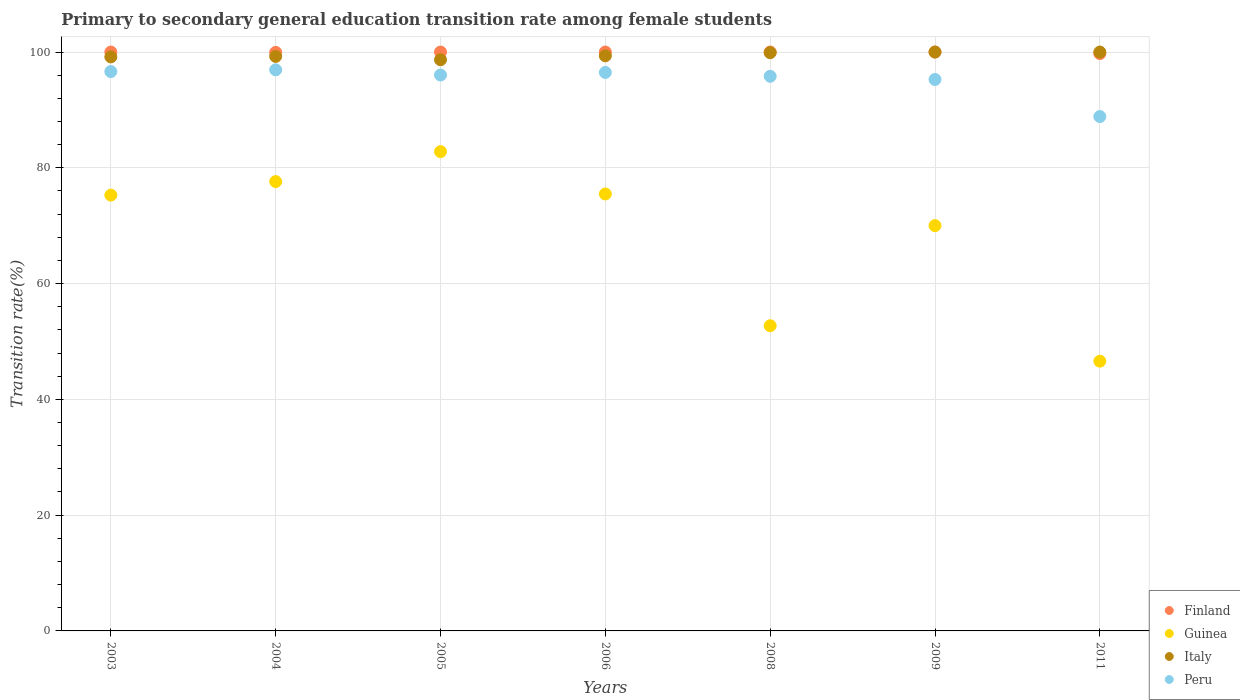How many different coloured dotlines are there?
Your answer should be very brief. 4. Is the number of dotlines equal to the number of legend labels?
Your answer should be compact. Yes. What is the transition rate in Guinea in 2003?
Keep it short and to the point. 75.28. Across all years, what is the maximum transition rate in Italy?
Your response must be concise. 100. Across all years, what is the minimum transition rate in Guinea?
Your answer should be very brief. 46.59. In which year was the transition rate in Peru maximum?
Offer a terse response. 2004. What is the total transition rate in Guinea in the graph?
Your answer should be compact. 480.51. What is the difference between the transition rate in Italy in 2003 and that in 2004?
Provide a short and direct response. -0.09. What is the difference between the transition rate in Italy in 2003 and the transition rate in Peru in 2008?
Ensure brevity in your answer.  3.35. What is the average transition rate in Guinea per year?
Your answer should be compact. 68.64. In the year 2008, what is the difference between the transition rate in Guinea and transition rate in Italy?
Your answer should be compact. -47.17. In how many years, is the transition rate in Finland greater than 68 %?
Make the answer very short. 7. What is the ratio of the transition rate in Finland in 2004 to that in 2005?
Offer a very short reply. 1. Is the difference between the transition rate in Guinea in 2004 and 2009 greater than the difference between the transition rate in Italy in 2004 and 2009?
Offer a terse response. Yes. What is the difference between the highest and the second highest transition rate in Guinea?
Offer a very short reply. 5.18. What is the difference between the highest and the lowest transition rate in Guinea?
Your answer should be compact. 36.2. In how many years, is the transition rate in Peru greater than the average transition rate in Peru taken over all years?
Your answer should be compact. 6. Is it the case that in every year, the sum of the transition rate in Guinea and transition rate in Peru  is greater than the sum of transition rate in Finland and transition rate in Italy?
Offer a terse response. No. Is it the case that in every year, the sum of the transition rate in Peru and transition rate in Guinea  is greater than the transition rate in Italy?
Offer a very short reply. Yes. Is the transition rate in Italy strictly less than the transition rate in Peru over the years?
Your response must be concise. No. How many dotlines are there?
Your answer should be very brief. 4. How many years are there in the graph?
Provide a short and direct response. 7. Are the values on the major ticks of Y-axis written in scientific E-notation?
Give a very brief answer. No. How are the legend labels stacked?
Offer a terse response. Vertical. What is the title of the graph?
Offer a terse response. Primary to secondary general education transition rate among female students. Does "Trinidad and Tobago" appear as one of the legend labels in the graph?
Your answer should be compact. No. What is the label or title of the X-axis?
Make the answer very short. Years. What is the label or title of the Y-axis?
Offer a terse response. Transition rate(%). What is the Transition rate(%) of Finland in 2003?
Your answer should be compact. 100. What is the Transition rate(%) of Guinea in 2003?
Your response must be concise. 75.28. What is the Transition rate(%) of Italy in 2003?
Provide a succinct answer. 99.16. What is the Transition rate(%) of Peru in 2003?
Provide a short and direct response. 96.63. What is the Transition rate(%) in Finland in 2004?
Make the answer very short. 99.95. What is the Transition rate(%) in Guinea in 2004?
Give a very brief answer. 77.62. What is the Transition rate(%) in Italy in 2004?
Provide a succinct answer. 99.24. What is the Transition rate(%) of Peru in 2004?
Provide a succinct answer. 96.92. What is the Transition rate(%) in Finland in 2005?
Your response must be concise. 100. What is the Transition rate(%) of Guinea in 2005?
Provide a short and direct response. 82.8. What is the Transition rate(%) of Italy in 2005?
Provide a short and direct response. 98.67. What is the Transition rate(%) of Peru in 2005?
Your answer should be very brief. 96.03. What is the Transition rate(%) in Guinea in 2006?
Offer a very short reply. 75.48. What is the Transition rate(%) of Italy in 2006?
Provide a short and direct response. 99.35. What is the Transition rate(%) of Peru in 2006?
Provide a succinct answer. 96.47. What is the Transition rate(%) of Finland in 2008?
Keep it short and to the point. 100. What is the Transition rate(%) in Guinea in 2008?
Keep it short and to the point. 52.72. What is the Transition rate(%) of Italy in 2008?
Offer a very short reply. 99.89. What is the Transition rate(%) in Peru in 2008?
Offer a very short reply. 95.81. What is the Transition rate(%) of Finland in 2009?
Ensure brevity in your answer.  100. What is the Transition rate(%) of Guinea in 2009?
Your answer should be very brief. 70.02. What is the Transition rate(%) in Italy in 2009?
Provide a succinct answer. 100. What is the Transition rate(%) of Peru in 2009?
Ensure brevity in your answer.  95.26. What is the Transition rate(%) of Finland in 2011?
Your response must be concise. 99.73. What is the Transition rate(%) of Guinea in 2011?
Your answer should be very brief. 46.59. What is the Transition rate(%) in Italy in 2011?
Offer a very short reply. 100. What is the Transition rate(%) of Peru in 2011?
Provide a short and direct response. 88.85. Across all years, what is the maximum Transition rate(%) of Finland?
Ensure brevity in your answer.  100. Across all years, what is the maximum Transition rate(%) in Guinea?
Offer a terse response. 82.8. Across all years, what is the maximum Transition rate(%) of Italy?
Ensure brevity in your answer.  100. Across all years, what is the maximum Transition rate(%) in Peru?
Make the answer very short. 96.92. Across all years, what is the minimum Transition rate(%) in Finland?
Make the answer very short. 99.73. Across all years, what is the minimum Transition rate(%) in Guinea?
Offer a terse response. 46.59. Across all years, what is the minimum Transition rate(%) in Italy?
Keep it short and to the point. 98.67. Across all years, what is the minimum Transition rate(%) of Peru?
Make the answer very short. 88.85. What is the total Transition rate(%) of Finland in the graph?
Provide a short and direct response. 699.68. What is the total Transition rate(%) in Guinea in the graph?
Keep it short and to the point. 480.51. What is the total Transition rate(%) in Italy in the graph?
Give a very brief answer. 696.3. What is the total Transition rate(%) of Peru in the graph?
Make the answer very short. 665.97. What is the difference between the Transition rate(%) in Finland in 2003 and that in 2004?
Your answer should be compact. 0.05. What is the difference between the Transition rate(%) of Guinea in 2003 and that in 2004?
Keep it short and to the point. -2.34. What is the difference between the Transition rate(%) of Italy in 2003 and that in 2004?
Your answer should be very brief. -0.09. What is the difference between the Transition rate(%) in Peru in 2003 and that in 2004?
Keep it short and to the point. -0.29. What is the difference between the Transition rate(%) in Guinea in 2003 and that in 2005?
Make the answer very short. -7.52. What is the difference between the Transition rate(%) of Italy in 2003 and that in 2005?
Keep it short and to the point. 0.49. What is the difference between the Transition rate(%) of Peru in 2003 and that in 2005?
Offer a very short reply. 0.6. What is the difference between the Transition rate(%) of Guinea in 2003 and that in 2006?
Ensure brevity in your answer.  -0.2. What is the difference between the Transition rate(%) of Italy in 2003 and that in 2006?
Offer a terse response. -0.19. What is the difference between the Transition rate(%) of Peru in 2003 and that in 2006?
Your response must be concise. 0.16. What is the difference between the Transition rate(%) in Finland in 2003 and that in 2008?
Offer a very short reply. 0. What is the difference between the Transition rate(%) of Guinea in 2003 and that in 2008?
Offer a terse response. 22.56. What is the difference between the Transition rate(%) in Italy in 2003 and that in 2008?
Your answer should be very brief. -0.73. What is the difference between the Transition rate(%) of Peru in 2003 and that in 2008?
Provide a succinct answer. 0.82. What is the difference between the Transition rate(%) of Finland in 2003 and that in 2009?
Provide a succinct answer. 0. What is the difference between the Transition rate(%) of Guinea in 2003 and that in 2009?
Offer a very short reply. 5.26. What is the difference between the Transition rate(%) of Italy in 2003 and that in 2009?
Offer a very short reply. -0.84. What is the difference between the Transition rate(%) in Peru in 2003 and that in 2009?
Provide a succinct answer. 1.37. What is the difference between the Transition rate(%) in Finland in 2003 and that in 2011?
Your answer should be compact. 0.27. What is the difference between the Transition rate(%) of Guinea in 2003 and that in 2011?
Offer a very short reply. 28.68. What is the difference between the Transition rate(%) in Italy in 2003 and that in 2011?
Make the answer very short. -0.84. What is the difference between the Transition rate(%) in Peru in 2003 and that in 2011?
Your response must be concise. 7.78. What is the difference between the Transition rate(%) of Finland in 2004 and that in 2005?
Offer a very short reply. -0.05. What is the difference between the Transition rate(%) of Guinea in 2004 and that in 2005?
Provide a short and direct response. -5.18. What is the difference between the Transition rate(%) in Italy in 2004 and that in 2005?
Your answer should be very brief. 0.57. What is the difference between the Transition rate(%) of Peru in 2004 and that in 2005?
Your answer should be compact. 0.89. What is the difference between the Transition rate(%) of Finland in 2004 and that in 2006?
Give a very brief answer. -0.05. What is the difference between the Transition rate(%) of Guinea in 2004 and that in 2006?
Ensure brevity in your answer.  2.14. What is the difference between the Transition rate(%) of Italy in 2004 and that in 2006?
Ensure brevity in your answer.  -0.1. What is the difference between the Transition rate(%) of Peru in 2004 and that in 2006?
Offer a very short reply. 0.45. What is the difference between the Transition rate(%) in Finland in 2004 and that in 2008?
Give a very brief answer. -0.05. What is the difference between the Transition rate(%) of Guinea in 2004 and that in 2008?
Keep it short and to the point. 24.9. What is the difference between the Transition rate(%) of Italy in 2004 and that in 2008?
Give a very brief answer. -0.64. What is the difference between the Transition rate(%) in Peru in 2004 and that in 2008?
Provide a short and direct response. 1.11. What is the difference between the Transition rate(%) in Finland in 2004 and that in 2009?
Provide a succinct answer. -0.05. What is the difference between the Transition rate(%) in Guinea in 2004 and that in 2009?
Give a very brief answer. 7.6. What is the difference between the Transition rate(%) of Italy in 2004 and that in 2009?
Your answer should be very brief. -0.76. What is the difference between the Transition rate(%) of Peru in 2004 and that in 2009?
Ensure brevity in your answer.  1.66. What is the difference between the Transition rate(%) of Finland in 2004 and that in 2011?
Your answer should be compact. 0.21. What is the difference between the Transition rate(%) in Guinea in 2004 and that in 2011?
Ensure brevity in your answer.  31.03. What is the difference between the Transition rate(%) of Italy in 2004 and that in 2011?
Ensure brevity in your answer.  -0.76. What is the difference between the Transition rate(%) of Peru in 2004 and that in 2011?
Give a very brief answer. 8.07. What is the difference between the Transition rate(%) in Finland in 2005 and that in 2006?
Your answer should be very brief. 0. What is the difference between the Transition rate(%) in Guinea in 2005 and that in 2006?
Your answer should be very brief. 7.32. What is the difference between the Transition rate(%) of Italy in 2005 and that in 2006?
Give a very brief answer. -0.68. What is the difference between the Transition rate(%) in Peru in 2005 and that in 2006?
Your answer should be compact. -0.44. What is the difference between the Transition rate(%) in Guinea in 2005 and that in 2008?
Your answer should be very brief. 30.08. What is the difference between the Transition rate(%) of Italy in 2005 and that in 2008?
Ensure brevity in your answer.  -1.22. What is the difference between the Transition rate(%) in Peru in 2005 and that in 2008?
Give a very brief answer. 0.22. What is the difference between the Transition rate(%) in Finland in 2005 and that in 2009?
Keep it short and to the point. 0. What is the difference between the Transition rate(%) in Guinea in 2005 and that in 2009?
Offer a very short reply. 12.78. What is the difference between the Transition rate(%) of Italy in 2005 and that in 2009?
Provide a short and direct response. -1.33. What is the difference between the Transition rate(%) of Peru in 2005 and that in 2009?
Provide a succinct answer. 0.77. What is the difference between the Transition rate(%) in Finland in 2005 and that in 2011?
Your answer should be compact. 0.27. What is the difference between the Transition rate(%) in Guinea in 2005 and that in 2011?
Ensure brevity in your answer.  36.2. What is the difference between the Transition rate(%) in Italy in 2005 and that in 2011?
Your answer should be compact. -1.33. What is the difference between the Transition rate(%) in Peru in 2005 and that in 2011?
Provide a short and direct response. 7.18. What is the difference between the Transition rate(%) of Guinea in 2006 and that in 2008?
Your answer should be compact. 22.76. What is the difference between the Transition rate(%) of Italy in 2006 and that in 2008?
Make the answer very short. -0.54. What is the difference between the Transition rate(%) in Peru in 2006 and that in 2008?
Make the answer very short. 0.66. What is the difference between the Transition rate(%) in Finland in 2006 and that in 2009?
Ensure brevity in your answer.  0. What is the difference between the Transition rate(%) of Guinea in 2006 and that in 2009?
Give a very brief answer. 5.47. What is the difference between the Transition rate(%) in Italy in 2006 and that in 2009?
Keep it short and to the point. -0.65. What is the difference between the Transition rate(%) in Peru in 2006 and that in 2009?
Offer a terse response. 1.21. What is the difference between the Transition rate(%) of Finland in 2006 and that in 2011?
Offer a very short reply. 0.27. What is the difference between the Transition rate(%) in Guinea in 2006 and that in 2011?
Provide a short and direct response. 28.89. What is the difference between the Transition rate(%) in Italy in 2006 and that in 2011?
Offer a very short reply. -0.65. What is the difference between the Transition rate(%) in Peru in 2006 and that in 2011?
Give a very brief answer. 7.62. What is the difference between the Transition rate(%) of Finland in 2008 and that in 2009?
Give a very brief answer. 0. What is the difference between the Transition rate(%) of Guinea in 2008 and that in 2009?
Your answer should be very brief. -17.3. What is the difference between the Transition rate(%) in Italy in 2008 and that in 2009?
Your answer should be very brief. -0.11. What is the difference between the Transition rate(%) in Peru in 2008 and that in 2009?
Make the answer very short. 0.55. What is the difference between the Transition rate(%) in Finland in 2008 and that in 2011?
Your response must be concise. 0.27. What is the difference between the Transition rate(%) in Guinea in 2008 and that in 2011?
Offer a very short reply. 6.12. What is the difference between the Transition rate(%) in Italy in 2008 and that in 2011?
Make the answer very short. -0.11. What is the difference between the Transition rate(%) in Peru in 2008 and that in 2011?
Ensure brevity in your answer.  6.96. What is the difference between the Transition rate(%) of Finland in 2009 and that in 2011?
Make the answer very short. 0.27. What is the difference between the Transition rate(%) in Guinea in 2009 and that in 2011?
Provide a succinct answer. 23.42. What is the difference between the Transition rate(%) of Italy in 2009 and that in 2011?
Your answer should be compact. 0. What is the difference between the Transition rate(%) of Peru in 2009 and that in 2011?
Keep it short and to the point. 6.41. What is the difference between the Transition rate(%) of Finland in 2003 and the Transition rate(%) of Guinea in 2004?
Your answer should be compact. 22.38. What is the difference between the Transition rate(%) in Finland in 2003 and the Transition rate(%) in Italy in 2004?
Provide a short and direct response. 0.76. What is the difference between the Transition rate(%) in Finland in 2003 and the Transition rate(%) in Peru in 2004?
Provide a short and direct response. 3.08. What is the difference between the Transition rate(%) of Guinea in 2003 and the Transition rate(%) of Italy in 2004?
Offer a very short reply. -23.96. What is the difference between the Transition rate(%) of Guinea in 2003 and the Transition rate(%) of Peru in 2004?
Your response must be concise. -21.64. What is the difference between the Transition rate(%) in Italy in 2003 and the Transition rate(%) in Peru in 2004?
Keep it short and to the point. 2.24. What is the difference between the Transition rate(%) of Finland in 2003 and the Transition rate(%) of Guinea in 2005?
Provide a succinct answer. 17.2. What is the difference between the Transition rate(%) of Finland in 2003 and the Transition rate(%) of Italy in 2005?
Offer a very short reply. 1.33. What is the difference between the Transition rate(%) in Finland in 2003 and the Transition rate(%) in Peru in 2005?
Give a very brief answer. 3.97. What is the difference between the Transition rate(%) of Guinea in 2003 and the Transition rate(%) of Italy in 2005?
Offer a terse response. -23.39. What is the difference between the Transition rate(%) of Guinea in 2003 and the Transition rate(%) of Peru in 2005?
Offer a terse response. -20.75. What is the difference between the Transition rate(%) in Italy in 2003 and the Transition rate(%) in Peru in 2005?
Offer a terse response. 3.13. What is the difference between the Transition rate(%) in Finland in 2003 and the Transition rate(%) in Guinea in 2006?
Your answer should be compact. 24.52. What is the difference between the Transition rate(%) in Finland in 2003 and the Transition rate(%) in Italy in 2006?
Keep it short and to the point. 0.65. What is the difference between the Transition rate(%) in Finland in 2003 and the Transition rate(%) in Peru in 2006?
Give a very brief answer. 3.53. What is the difference between the Transition rate(%) in Guinea in 2003 and the Transition rate(%) in Italy in 2006?
Provide a succinct answer. -24.07. What is the difference between the Transition rate(%) of Guinea in 2003 and the Transition rate(%) of Peru in 2006?
Provide a succinct answer. -21.19. What is the difference between the Transition rate(%) in Italy in 2003 and the Transition rate(%) in Peru in 2006?
Provide a short and direct response. 2.69. What is the difference between the Transition rate(%) of Finland in 2003 and the Transition rate(%) of Guinea in 2008?
Offer a terse response. 47.28. What is the difference between the Transition rate(%) of Finland in 2003 and the Transition rate(%) of Italy in 2008?
Your answer should be compact. 0.11. What is the difference between the Transition rate(%) in Finland in 2003 and the Transition rate(%) in Peru in 2008?
Offer a very short reply. 4.19. What is the difference between the Transition rate(%) in Guinea in 2003 and the Transition rate(%) in Italy in 2008?
Offer a very short reply. -24.61. What is the difference between the Transition rate(%) in Guinea in 2003 and the Transition rate(%) in Peru in 2008?
Give a very brief answer. -20.53. What is the difference between the Transition rate(%) of Italy in 2003 and the Transition rate(%) of Peru in 2008?
Make the answer very short. 3.35. What is the difference between the Transition rate(%) in Finland in 2003 and the Transition rate(%) in Guinea in 2009?
Offer a very short reply. 29.98. What is the difference between the Transition rate(%) in Finland in 2003 and the Transition rate(%) in Peru in 2009?
Your answer should be compact. 4.74. What is the difference between the Transition rate(%) in Guinea in 2003 and the Transition rate(%) in Italy in 2009?
Your answer should be very brief. -24.72. What is the difference between the Transition rate(%) in Guinea in 2003 and the Transition rate(%) in Peru in 2009?
Offer a very short reply. -19.98. What is the difference between the Transition rate(%) of Italy in 2003 and the Transition rate(%) of Peru in 2009?
Your response must be concise. 3.9. What is the difference between the Transition rate(%) in Finland in 2003 and the Transition rate(%) in Guinea in 2011?
Give a very brief answer. 53.41. What is the difference between the Transition rate(%) in Finland in 2003 and the Transition rate(%) in Italy in 2011?
Provide a short and direct response. 0. What is the difference between the Transition rate(%) in Finland in 2003 and the Transition rate(%) in Peru in 2011?
Your answer should be compact. 11.15. What is the difference between the Transition rate(%) in Guinea in 2003 and the Transition rate(%) in Italy in 2011?
Your response must be concise. -24.72. What is the difference between the Transition rate(%) in Guinea in 2003 and the Transition rate(%) in Peru in 2011?
Provide a succinct answer. -13.57. What is the difference between the Transition rate(%) in Italy in 2003 and the Transition rate(%) in Peru in 2011?
Make the answer very short. 10.3. What is the difference between the Transition rate(%) in Finland in 2004 and the Transition rate(%) in Guinea in 2005?
Your answer should be very brief. 17.15. What is the difference between the Transition rate(%) in Finland in 2004 and the Transition rate(%) in Italy in 2005?
Your response must be concise. 1.28. What is the difference between the Transition rate(%) in Finland in 2004 and the Transition rate(%) in Peru in 2005?
Ensure brevity in your answer.  3.92. What is the difference between the Transition rate(%) in Guinea in 2004 and the Transition rate(%) in Italy in 2005?
Make the answer very short. -21.05. What is the difference between the Transition rate(%) in Guinea in 2004 and the Transition rate(%) in Peru in 2005?
Offer a very short reply. -18.41. What is the difference between the Transition rate(%) of Italy in 2004 and the Transition rate(%) of Peru in 2005?
Ensure brevity in your answer.  3.21. What is the difference between the Transition rate(%) of Finland in 2004 and the Transition rate(%) of Guinea in 2006?
Give a very brief answer. 24.46. What is the difference between the Transition rate(%) of Finland in 2004 and the Transition rate(%) of Italy in 2006?
Your answer should be compact. 0.6. What is the difference between the Transition rate(%) of Finland in 2004 and the Transition rate(%) of Peru in 2006?
Provide a short and direct response. 3.47. What is the difference between the Transition rate(%) of Guinea in 2004 and the Transition rate(%) of Italy in 2006?
Offer a very short reply. -21.72. What is the difference between the Transition rate(%) in Guinea in 2004 and the Transition rate(%) in Peru in 2006?
Provide a short and direct response. -18.85. What is the difference between the Transition rate(%) of Italy in 2004 and the Transition rate(%) of Peru in 2006?
Offer a terse response. 2.77. What is the difference between the Transition rate(%) of Finland in 2004 and the Transition rate(%) of Guinea in 2008?
Offer a terse response. 47.23. What is the difference between the Transition rate(%) in Finland in 2004 and the Transition rate(%) in Italy in 2008?
Offer a terse response. 0.06. What is the difference between the Transition rate(%) of Finland in 2004 and the Transition rate(%) of Peru in 2008?
Offer a very short reply. 4.14. What is the difference between the Transition rate(%) in Guinea in 2004 and the Transition rate(%) in Italy in 2008?
Provide a short and direct response. -22.27. What is the difference between the Transition rate(%) in Guinea in 2004 and the Transition rate(%) in Peru in 2008?
Offer a very short reply. -18.19. What is the difference between the Transition rate(%) of Italy in 2004 and the Transition rate(%) of Peru in 2008?
Offer a terse response. 3.43. What is the difference between the Transition rate(%) of Finland in 2004 and the Transition rate(%) of Guinea in 2009?
Give a very brief answer. 29.93. What is the difference between the Transition rate(%) of Finland in 2004 and the Transition rate(%) of Italy in 2009?
Your response must be concise. -0.05. What is the difference between the Transition rate(%) in Finland in 2004 and the Transition rate(%) in Peru in 2009?
Provide a short and direct response. 4.69. What is the difference between the Transition rate(%) in Guinea in 2004 and the Transition rate(%) in Italy in 2009?
Your answer should be compact. -22.38. What is the difference between the Transition rate(%) of Guinea in 2004 and the Transition rate(%) of Peru in 2009?
Your answer should be very brief. -17.64. What is the difference between the Transition rate(%) of Italy in 2004 and the Transition rate(%) of Peru in 2009?
Your answer should be very brief. 3.98. What is the difference between the Transition rate(%) of Finland in 2004 and the Transition rate(%) of Guinea in 2011?
Make the answer very short. 53.35. What is the difference between the Transition rate(%) of Finland in 2004 and the Transition rate(%) of Italy in 2011?
Offer a very short reply. -0.05. What is the difference between the Transition rate(%) in Finland in 2004 and the Transition rate(%) in Peru in 2011?
Provide a short and direct response. 11.09. What is the difference between the Transition rate(%) of Guinea in 2004 and the Transition rate(%) of Italy in 2011?
Your answer should be compact. -22.38. What is the difference between the Transition rate(%) in Guinea in 2004 and the Transition rate(%) in Peru in 2011?
Ensure brevity in your answer.  -11.23. What is the difference between the Transition rate(%) in Italy in 2004 and the Transition rate(%) in Peru in 2011?
Your answer should be very brief. 10.39. What is the difference between the Transition rate(%) of Finland in 2005 and the Transition rate(%) of Guinea in 2006?
Your answer should be compact. 24.52. What is the difference between the Transition rate(%) in Finland in 2005 and the Transition rate(%) in Italy in 2006?
Keep it short and to the point. 0.65. What is the difference between the Transition rate(%) of Finland in 2005 and the Transition rate(%) of Peru in 2006?
Provide a succinct answer. 3.53. What is the difference between the Transition rate(%) in Guinea in 2005 and the Transition rate(%) in Italy in 2006?
Give a very brief answer. -16.55. What is the difference between the Transition rate(%) in Guinea in 2005 and the Transition rate(%) in Peru in 2006?
Provide a short and direct response. -13.67. What is the difference between the Transition rate(%) in Italy in 2005 and the Transition rate(%) in Peru in 2006?
Provide a succinct answer. 2.2. What is the difference between the Transition rate(%) in Finland in 2005 and the Transition rate(%) in Guinea in 2008?
Give a very brief answer. 47.28. What is the difference between the Transition rate(%) of Finland in 2005 and the Transition rate(%) of Italy in 2008?
Provide a short and direct response. 0.11. What is the difference between the Transition rate(%) of Finland in 2005 and the Transition rate(%) of Peru in 2008?
Make the answer very short. 4.19. What is the difference between the Transition rate(%) in Guinea in 2005 and the Transition rate(%) in Italy in 2008?
Provide a succinct answer. -17.09. What is the difference between the Transition rate(%) in Guinea in 2005 and the Transition rate(%) in Peru in 2008?
Make the answer very short. -13.01. What is the difference between the Transition rate(%) of Italy in 2005 and the Transition rate(%) of Peru in 2008?
Ensure brevity in your answer.  2.86. What is the difference between the Transition rate(%) in Finland in 2005 and the Transition rate(%) in Guinea in 2009?
Your response must be concise. 29.98. What is the difference between the Transition rate(%) in Finland in 2005 and the Transition rate(%) in Peru in 2009?
Give a very brief answer. 4.74. What is the difference between the Transition rate(%) of Guinea in 2005 and the Transition rate(%) of Italy in 2009?
Your answer should be very brief. -17.2. What is the difference between the Transition rate(%) in Guinea in 2005 and the Transition rate(%) in Peru in 2009?
Your answer should be very brief. -12.46. What is the difference between the Transition rate(%) in Italy in 2005 and the Transition rate(%) in Peru in 2009?
Make the answer very short. 3.41. What is the difference between the Transition rate(%) of Finland in 2005 and the Transition rate(%) of Guinea in 2011?
Provide a succinct answer. 53.41. What is the difference between the Transition rate(%) in Finland in 2005 and the Transition rate(%) in Peru in 2011?
Ensure brevity in your answer.  11.15. What is the difference between the Transition rate(%) in Guinea in 2005 and the Transition rate(%) in Italy in 2011?
Make the answer very short. -17.2. What is the difference between the Transition rate(%) of Guinea in 2005 and the Transition rate(%) of Peru in 2011?
Your answer should be very brief. -6.05. What is the difference between the Transition rate(%) in Italy in 2005 and the Transition rate(%) in Peru in 2011?
Offer a very short reply. 9.82. What is the difference between the Transition rate(%) of Finland in 2006 and the Transition rate(%) of Guinea in 2008?
Keep it short and to the point. 47.28. What is the difference between the Transition rate(%) in Finland in 2006 and the Transition rate(%) in Italy in 2008?
Your answer should be compact. 0.11. What is the difference between the Transition rate(%) in Finland in 2006 and the Transition rate(%) in Peru in 2008?
Your answer should be compact. 4.19. What is the difference between the Transition rate(%) in Guinea in 2006 and the Transition rate(%) in Italy in 2008?
Offer a terse response. -24.4. What is the difference between the Transition rate(%) of Guinea in 2006 and the Transition rate(%) of Peru in 2008?
Make the answer very short. -20.33. What is the difference between the Transition rate(%) of Italy in 2006 and the Transition rate(%) of Peru in 2008?
Keep it short and to the point. 3.54. What is the difference between the Transition rate(%) of Finland in 2006 and the Transition rate(%) of Guinea in 2009?
Give a very brief answer. 29.98. What is the difference between the Transition rate(%) of Finland in 2006 and the Transition rate(%) of Italy in 2009?
Offer a terse response. 0. What is the difference between the Transition rate(%) in Finland in 2006 and the Transition rate(%) in Peru in 2009?
Ensure brevity in your answer.  4.74. What is the difference between the Transition rate(%) in Guinea in 2006 and the Transition rate(%) in Italy in 2009?
Keep it short and to the point. -24.52. What is the difference between the Transition rate(%) in Guinea in 2006 and the Transition rate(%) in Peru in 2009?
Provide a short and direct response. -19.78. What is the difference between the Transition rate(%) in Italy in 2006 and the Transition rate(%) in Peru in 2009?
Give a very brief answer. 4.09. What is the difference between the Transition rate(%) of Finland in 2006 and the Transition rate(%) of Guinea in 2011?
Provide a short and direct response. 53.41. What is the difference between the Transition rate(%) of Finland in 2006 and the Transition rate(%) of Peru in 2011?
Provide a succinct answer. 11.15. What is the difference between the Transition rate(%) in Guinea in 2006 and the Transition rate(%) in Italy in 2011?
Your answer should be very brief. -24.52. What is the difference between the Transition rate(%) in Guinea in 2006 and the Transition rate(%) in Peru in 2011?
Offer a terse response. -13.37. What is the difference between the Transition rate(%) in Italy in 2006 and the Transition rate(%) in Peru in 2011?
Provide a succinct answer. 10.49. What is the difference between the Transition rate(%) in Finland in 2008 and the Transition rate(%) in Guinea in 2009?
Ensure brevity in your answer.  29.98. What is the difference between the Transition rate(%) of Finland in 2008 and the Transition rate(%) of Italy in 2009?
Ensure brevity in your answer.  0. What is the difference between the Transition rate(%) in Finland in 2008 and the Transition rate(%) in Peru in 2009?
Provide a succinct answer. 4.74. What is the difference between the Transition rate(%) of Guinea in 2008 and the Transition rate(%) of Italy in 2009?
Give a very brief answer. -47.28. What is the difference between the Transition rate(%) in Guinea in 2008 and the Transition rate(%) in Peru in 2009?
Give a very brief answer. -42.54. What is the difference between the Transition rate(%) in Italy in 2008 and the Transition rate(%) in Peru in 2009?
Make the answer very short. 4.63. What is the difference between the Transition rate(%) in Finland in 2008 and the Transition rate(%) in Guinea in 2011?
Provide a succinct answer. 53.41. What is the difference between the Transition rate(%) of Finland in 2008 and the Transition rate(%) of Peru in 2011?
Your answer should be very brief. 11.15. What is the difference between the Transition rate(%) of Guinea in 2008 and the Transition rate(%) of Italy in 2011?
Offer a very short reply. -47.28. What is the difference between the Transition rate(%) of Guinea in 2008 and the Transition rate(%) of Peru in 2011?
Give a very brief answer. -36.13. What is the difference between the Transition rate(%) in Italy in 2008 and the Transition rate(%) in Peru in 2011?
Make the answer very short. 11.03. What is the difference between the Transition rate(%) in Finland in 2009 and the Transition rate(%) in Guinea in 2011?
Ensure brevity in your answer.  53.41. What is the difference between the Transition rate(%) of Finland in 2009 and the Transition rate(%) of Italy in 2011?
Provide a succinct answer. 0. What is the difference between the Transition rate(%) of Finland in 2009 and the Transition rate(%) of Peru in 2011?
Offer a terse response. 11.15. What is the difference between the Transition rate(%) of Guinea in 2009 and the Transition rate(%) of Italy in 2011?
Your answer should be very brief. -29.98. What is the difference between the Transition rate(%) of Guinea in 2009 and the Transition rate(%) of Peru in 2011?
Your answer should be very brief. -18.84. What is the difference between the Transition rate(%) in Italy in 2009 and the Transition rate(%) in Peru in 2011?
Your answer should be very brief. 11.15. What is the average Transition rate(%) of Finland per year?
Your answer should be very brief. 99.95. What is the average Transition rate(%) of Guinea per year?
Provide a succinct answer. 68.64. What is the average Transition rate(%) of Italy per year?
Provide a short and direct response. 99.47. What is the average Transition rate(%) in Peru per year?
Keep it short and to the point. 95.14. In the year 2003, what is the difference between the Transition rate(%) in Finland and Transition rate(%) in Guinea?
Offer a very short reply. 24.72. In the year 2003, what is the difference between the Transition rate(%) of Finland and Transition rate(%) of Italy?
Ensure brevity in your answer.  0.84. In the year 2003, what is the difference between the Transition rate(%) in Finland and Transition rate(%) in Peru?
Offer a very short reply. 3.37. In the year 2003, what is the difference between the Transition rate(%) in Guinea and Transition rate(%) in Italy?
Provide a short and direct response. -23.88. In the year 2003, what is the difference between the Transition rate(%) in Guinea and Transition rate(%) in Peru?
Offer a very short reply. -21.35. In the year 2003, what is the difference between the Transition rate(%) in Italy and Transition rate(%) in Peru?
Ensure brevity in your answer.  2.53. In the year 2004, what is the difference between the Transition rate(%) of Finland and Transition rate(%) of Guinea?
Offer a very short reply. 22.32. In the year 2004, what is the difference between the Transition rate(%) in Finland and Transition rate(%) in Italy?
Ensure brevity in your answer.  0.7. In the year 2004, what is the difference between the Transition rate(%) in Finland and Transition rate(%) in Peru?
Give a very brief answer. 3.02. In the year 2004, what is the difference between the Transition rate(%) in Guinea and Transition rate(%) in Italy?
Provide a short and direct response. -21.62. In the year 2004, what is the difference between the Transition rate(%) in Guinea and Transition rate(%) in Peru?
Offer a terse response. -19.3. In the year 2004, what is the difference between the Transition rate(%) in Italy and Transition rate(%) in Peru?
Your answer should be compact. 2.32. In the year 2005, what is the difference between the Transition rate(%) in Finland and Transition rate(%) in Guinea?
Ensure brevity in your answer.  17.2. In the year 2005, what is the difference between the Transition rate(%) in Finland and Transition rate(%) in Italy?
Provide a succinct answer. 1.33. In the year 2005, what is the difference between the Transition rate(%) of Finland and Transition rate(%) of Peru?
Provide a succinct answer. 3.97. In the year 2005, what is the difference between the Transition rate(%) of Guinea and Transition rate(%) of Italy?
Provide a short and direct response. -15.87. In the year 2005, what is the difference between the Transition rate(%) of Guinea and Transition rate(%) of Peru?
Make the answer very short. -13.23. In the year 2005, what is the difference between the Transition rate(%) of Italy and Transition rate(%) of Peru?
Provide a short and direct response. 2.64. In the year 2006, what is the difference between the Transition rate(%) in Finland and Transition rate(%) in Guinea?
Offer a very short reply. 24.52. In the year 2006, what is the difference between the Transition rate(%) of Finland and Transition rate(%) of Italy?
Keep it short and to the point. 0.65. In the year 2006, what is the difference between the Transition rate(%) in Finland and Transition rate(%) in Peru?
Keep it short and to the point. 3.53. In the year 2006, what is the difference between the Transition rate(%) of Guinea and Transition rate(%) of Italy?
Keep it short and to the point. -23.86. In the year 2006, what is the difference between the Transition rate(%) in Guinea and Transition rate(%) in Peru?
Your answer should be compact. -20.99. In the year 2006, what is the difference between the Transition rate(%) in Italy and Transition rate(%) in Peru?
Keep it short and to the point. 2.87. In the year 2008, what is the difference between the Transition rate(%) of Finland and Transition rate(%) of Guinea?
Give a very brief answer. 47.28. In the year 2008, what is the difference between the Transition rate(%) in Finland and Transition rate(%) in Italy?
Your answer should be very brief. 0.11. In the year 2008, what is the difference between the Transition rate(%) of Finland and Transition rate(%) of Peru?
Ensure brevity in your answer.  4.19. In the year 2008, what is the difference between the Transition rate(%) in Guinea and Transition rate(%) in Italy?
Your response must be concise. -47.17. In the year 2008, what is the difference between the Transition rate(%) in Guinea and Transition rate(%) in Peru?
Your answer should be very brief. -43.09. In the year 2008, what is the difference between the Transition rate(%) in Italy and Transition rate(%) in Peru?
Provide a succinct answer. 4.08. In the year 2009, what is the difference between the Transition rate(%) of Finland and Transition rate(%) of Guinea?
Your answer should be very brief. 29.98. In the year 2009, what is the difference between the Transition rate(%) of Finland and Transition rate(%) of Italy?
Give a very brief answer. 0. In the year 2009, what is the difference between the Transition rate(%) of Finland and Transition rate(%) of Peru?
Ensure brevity in your answer.  4.74. In the year 2009, what is the difference between the Transition rate(%) in Guinea and Transition rate(%) in Italy?
Provide a succinct answer. -29.98. In the year 2009, what is the difference between the Transition rate(%) of Guinea and Transition rate(%) of Peru?
Your answer should be very brief. -25.24. In the year 2009, what is the difference between the Transition rate(%) of Italy and Transition rate(%) of Peru?
Offer a very short reply. 4.74. In the year 2011, what is the difference between the Transition rate(%) of Finland and Transition rate(%) of Guinea?
Ensure brevity in your answer.  53.14. In the year 2011, what is the difference between the Transition rate(%) in Finland and Transition rate(%) in Italy?
Keep it short and to the point. -0.27. In the year 2011, what is the difference between the Transition rate(%) of Finland and Transition rate(%) of Peru?
Your answer should be compact. 10.88. In the year 2011, what is the difference between the Transition rate(%) in Guinea and Transition rate(%) in Italy?
Offer a terse response. -53.41. In the year 2011, what is the difference between the Transition rate(%) of Guinea and Transition rate(%) of Peru?
Offer a terse response. -42.26. In the year 2011, what is the difference between the Transition rate(%) of Italy and Transition rate(%) of Peru?
Keep it short and to the point. 11.15. What is the ratio of the Transition rate(%) of Guinea in 2003 to that in 2004?
Your response must be concise. 0.97. What is the ratio of the Transition rate(%) in Italy in 2003 to that in 2004?
Your answer should be very brief. 1. What is the ratio of the Transition rate(%) in Finland in 2003 to that in 2005?
Make the answer very short. 1. What is the ratio of the Transition rate(%) of Guinea in 2003 to that in 2005?
Make the answer very short. 0.91. What is the ratio of the Transition rate(%) in Finland in 2003 to that in 2006?
Your response must be concise. 1. What is the ratio of the Transition rate(%) in Guinea in 2003 to that in 2006?
Give a very brief answer. 1. What is the ratio of the Transition rate(%) in Peru in 2003 to that in 2006?
Offer a very short reply. 1. What is the ratio of the Transition rate(%) of Finland in 2003 to that in 2008?
Keep it short and to the point. 1. What is the ratio of the Transition rate(%) in Guinea in 2003 to that in 2008?
Your answer should be very brief. 1.43. What is the ratio of the Transition rate(%) of Italy in 2003 to that in 2008?
Give a very brief answer. 0.99. What is the ratio of the Transition rate(%) in Peru in 2003 to that in 2008?
Offer a very short reply. 1.01. What is the ratio of the Transition rate(%) of Guinea in 2003 to that in 2009?
Give a very brief answer. 1.08. What is the ratio of the Transition rate(%) of Peru in 2003 to that in 2009?
Your answer should be very brief. 1.01. What is the ratio of the Transition rate(%) in Guinea in 2003 to that in 2011?
Your response must be concise. 1.62. What is the ratio of the Transition rate(%) in Peru in 2003 to that in 2011?
Make the answer very short. 1.09. What is the ratio of the Transition rate(%) of Guinea in 2004 to that in 2005?
Offer a terse response. 0.94. What is the ratio of the Transition rate(%) in Peru in 2004 to that in 2005?
Your answer should be very brief. 1.01. What is the ratio of the Transition rate(%) of Finland in 2004 to that in 2006?
Your answer should be compact. 1. What is the ratio of the Transition rate(%) in Guinea in 2004 to that in 2006?
Provide a succinct answer. 1.03. What is the ratio of the Transition rate(%) of Peru in 2004 to that in 2006?
Provide a short and direct response. 1. What is the ratio of the Transition rate(%) in Finland in 2004 to that in 2008?
Offer a terse response. 1. What is the ratio of the Transition rate(%) in Guinea in 2004 to that in 2008?
Offer a very short reply. 1.47. What is the ratio of the Transition rate(%) of Italy in 2004 to that in 2008?
Provide a short and direct response. 0.99. What is the ratio of the Transition rate(%) in Peru in 2004 to that in 2008?
Offer a terse response. 1.01. What is the ratio of the Transition rate(%) of Finland in 2004 to that in 2009?
Provide a succinct answer. 1. What is the ratio of the Transition rate(%) of Guinea in 2004 to that in 2009?
Offer a very short reply. 1.11. What is the ratio of the Transition rate(%) in Peru in 2004 to that in 2009?
Provide a short and direct response. 1.02. What is the ratio of the Transition rate(%) in Finland in 2004 to that in 2011?
Your response must be concise. 1. What is the ratio of the Transition rate(%) in Guinea in 2004 to that in 2011?
Give a very brief answer. 1.67. What is the ratio of the Transition rate(%) of Italy in 2004 to that in 2011?
Provide a succinct answer. 0.99. What is the ratio of the Transition rate(%) of Peru in 2004 to that in 2011?
Offer a very short reply. 1.09. What is the ratio of the Transition rate(%) in Guinea in 2005 to that in 2006?
Keep it short and to the point. 1.1. What is the ratio of the Transition rate(%) of Peru in 2005 to that in 2006?
Offer a terse response. 1. What is the ratio of the Transition rate(%) in Guinea in 2005 to that in 2008?
Offer a very short reply. 1.57. What is the ratio of the Transition rate(%) of Italy in 2005 to that in 2008?
Make the answer very short. 0.99. What is the ratio of the Transition rate(%) of Peru in 2005 to that in 2008?
Keep it short and to the point. 1. What is the ratio of the Transition rate(%) in Guinea in 2005 to that in 2009?
Ensure brevity in your answer.  1.18. What is the ratio of the Transition rate(%) in Italy in 2005 to that in 2009?
Offer a very short reply. 0.99. What is the ratio of the Transition rate(%) of Peru in 2005 to that in 2009?
Your answer should be very brief. 1.01. What is the ratio of the Transition rate(%) of Guinea in 2005 to that in 2011?
Your response must be concise. 1.78. What is the ratio of the Transition rate(%) of Italy in 2005 to that in 2011?
Offer a very short reply. 0.99. What is the ratio of the Transition rate(%) in Peru in 2005 to that in 2011?
Keep it short and to the point. 1.08. What is the ratio of the Transition rate(%) of Finland in 2006 to that in 2008?
Make the answer very short. 1. What is the ratio of the Transition rate(%) of Guinea in 2006 to that in 2008?
Your answer should be compact. 1.43. What is the ratio of the Transition rate(%) of Italy in 2006 to that in 2008?
Your response must be concise. 0.99. What is the ratio of the Transition rate(%) of Finland in 2006 to that in 2009?
Your response must be concise. 1. What is the ratio of the Transition rate(%) in Guinea in 2006 to that in 2009?
Your answer should be compact. 1.08. What is the ratio of the Transition rate(%) of Italy in 2006 to that in 2009?
Offer a terse response. 0.99. What is the ratio of the Transition rate(%) in Peru in 2006 to that in 2009?
Provide a short and direct response. 1.01. What is the ratio of the Transition rate(%) in Guinea in 2006 to that in 2011?
Give a very brief answer. 1.62. What is the ratio of the Transition rate(%) in Peru in 2006 to that in 2011?
Your answer should be very brief. 1.09. What is the ratio of the Transition rate(%) in Finland in 2008 to that in 2009?
Give a very brief answer. 1. What is the ratio of the Transition rate(%) of Guinea in 2008 to that in 2009?
Offer a terse response. 0.75. What is the ratio of the Transition rate(%) of Finland in 2008 to that in 2011?
Keep it short and to the point. 1. What is the ratio of the Transition rate(%) in Guinea in 2008 to that in 2011?
Offer a very short reply. 1.13. What is the ratio of the Transition rate(%) in Peru in 2008 to that in 2011?
Ensure brevity in your answer.  1.08. What is the ratio of the Transition rate(%) in Finland in 2009 to that in 2011?
Provide a short and direct response. 1. What is the ratio of the Transition rate(%) of Guinea in 2009 to that in 2011?
Offer a very short reply. 1.5. What is the ratio of the Transition rate(%) in Peru in 2009 to that in 2011?
Offer a terse response. 1.07. What is the difference between the highest and the second highest Transition rate(%) of Finland?
Your answer should be very brief. 0. What is the difference between the highest and the second highest Transition rate(%) in Guinea?
Make the answer very short. 5.18. What is the difference between the highest and the second highest Transition rate(%) of Peru?
Provide a short and direct response. 0.29. What is the difference between the highest and the lowest Transition rate(%) in Finland?
Offer a terse response. 0.27. What is the difference between the highest and the lowest Transition rate(%) of Guinea?
Make the answer very short. 36.2. What is the difference between the highest and the lowest Transition rate(%) of Italy?
Your answer should be very brief. 1.33. What is the difference between the highest and the lowest Transition rate(%) in Peru?
Your response must be concise. 8.07. 